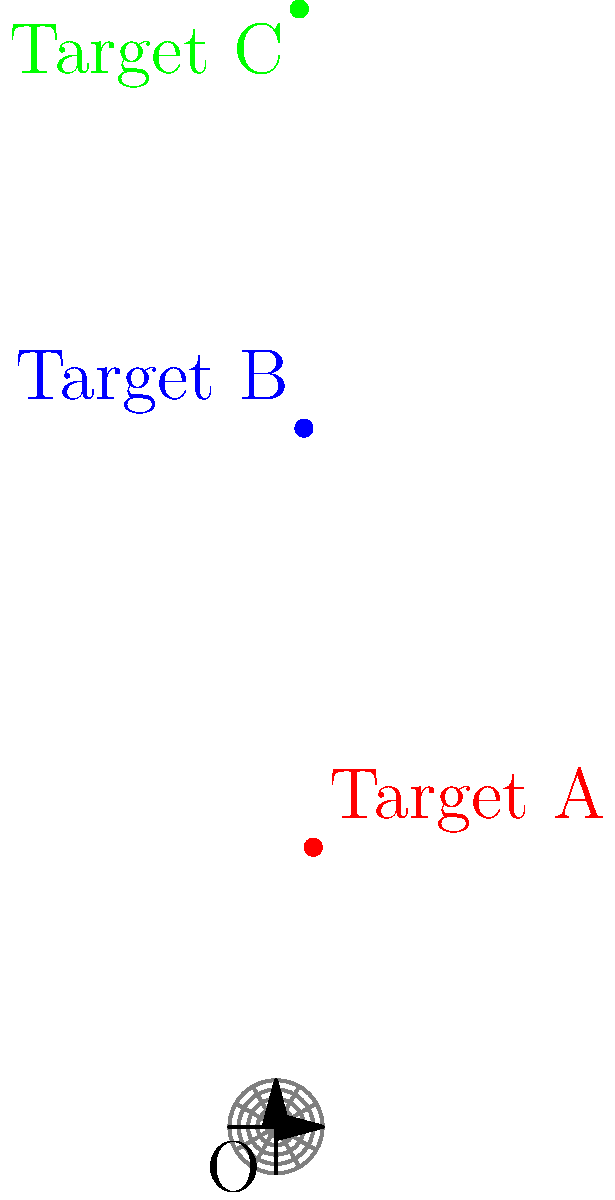Three moving targets (A, B, and C) are being tracked on a polar coordinate system. At a specific time, their positions are as follows:

Target A: $(8, 60°)$
Target B: $(6, 150°)$
Target C: $(5, 240°)$

Calculate the area of the triangle formed by these three targets. Round your answer to two decimal places. To solve this problem, we'll follow these steps:

1) First, convert the polar coordinates $(r, \theta)$ to Cartesian coordinates $(x, y)$ using the formulas:
   $x = r \cos(\theta)$
   $y = r \sin(\theta)$

   For Target A: $(8, 60°)$
   $x_A = 8 \cos(60°) = 4$
   $y_A = 8 \sin(60°) = 6.93$

   For Target B: $(6, 150°)$
   $x_B = 6 \cos(150°) = -5.20$
   $y_B = 6 \sin(150°) = 3$

   For Target C: $(5, 240°)$
   $x_C = 5 \cos(240°) = -2.5$
   $y_C = 5 \sin(240°) = -4.33$

2) Now that we have the Cartesian coordinates, we can use the formula for the area of a triangle given three points:

   Area = $\frac{1}{2}|x_A(y_B - y_C) + x_B(y_C - y_A) + x_C(y_A - y_B)|$

3) Substituting our values:

   Area = $\frac{1}{2}|4(3 - (-4.33)) + (-5.20)((-4.33) - 6.93) + (-2.5)(6.93 - 3)|$

4) Simplifying:

   Area = $\frac{1}{2}|4(7.33) + (-5.20)(-11.26) + (-2.5)(3.93)|$
   Area = $\frac{1}{2}|29.32 + 58.55 - 9.825|$
   Area = $\frac{1}{2}|78.045|$
   Area = 39.02

5) Rounding to two decimal places: 39.02
Answer: 39.02 square units 